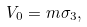Convert formula to latex. <formula><loc_0><loc_0><loc_500><loc_500>V _ { 0 } = m \sigma _ { 3 } ,</formula> 